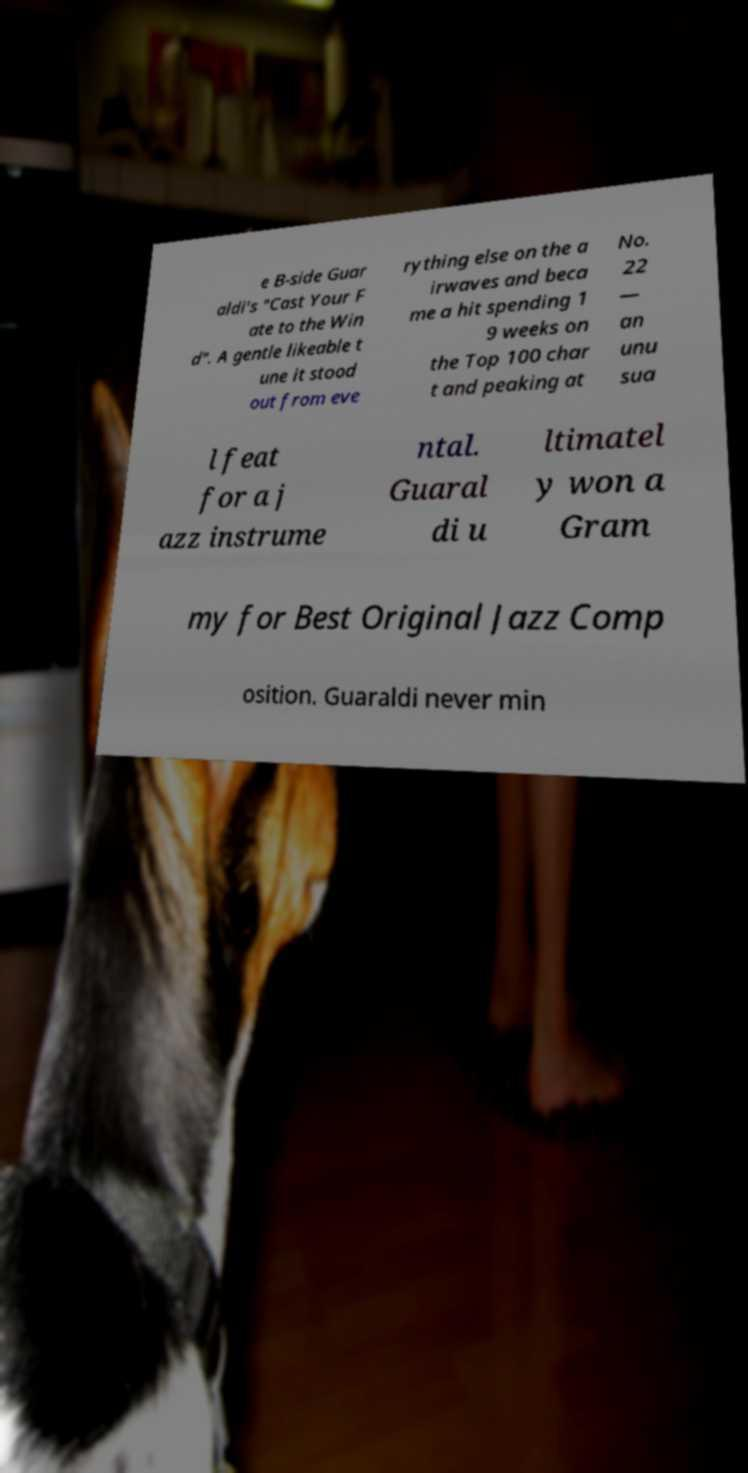What messages or text are displayed in this image? I need them in a readable, typed format. e B-side Guar aldi's "Cast Your F ate to the Win d". A gentle likeable t une it stood out from eve rything else on the a irwaves and beca me a hit spending 1 9 weeks on the Top 100 char t and peaking at No. 22 — an unu sua l feat for a j azz instrume ntal. Guaral di u ltimatel y won a Gram my for Best Original Jazz Comp osition. Guaraldi never min 